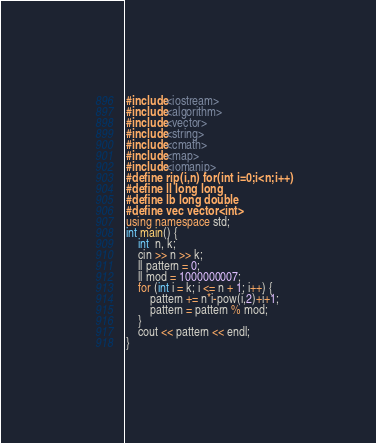<code> <loc_0><loc_0><loc_500><loc_500><_C++_>#include<iostream>
#include<algorithm>
#include<vector>
#include<string>
#include<cmath>
#include<map>
#include<iomanip>
#define rip(i,n) for(int i=0;i<n;i++)
#define ll long long
#define lb long double
#define vec vector<int>
using namespace std;
int main() {
	int  n, k;
	cin >> n >> k;
	ll pattern = 0;
	ll mod = 1000000007;
	for (int i = k; i <= n + 1; i++) {
		pattern += n*i-pow(i,2)+i+1;
		pattern = pattern % mod;
	}
	cout << pattern << endl;
}</code> 